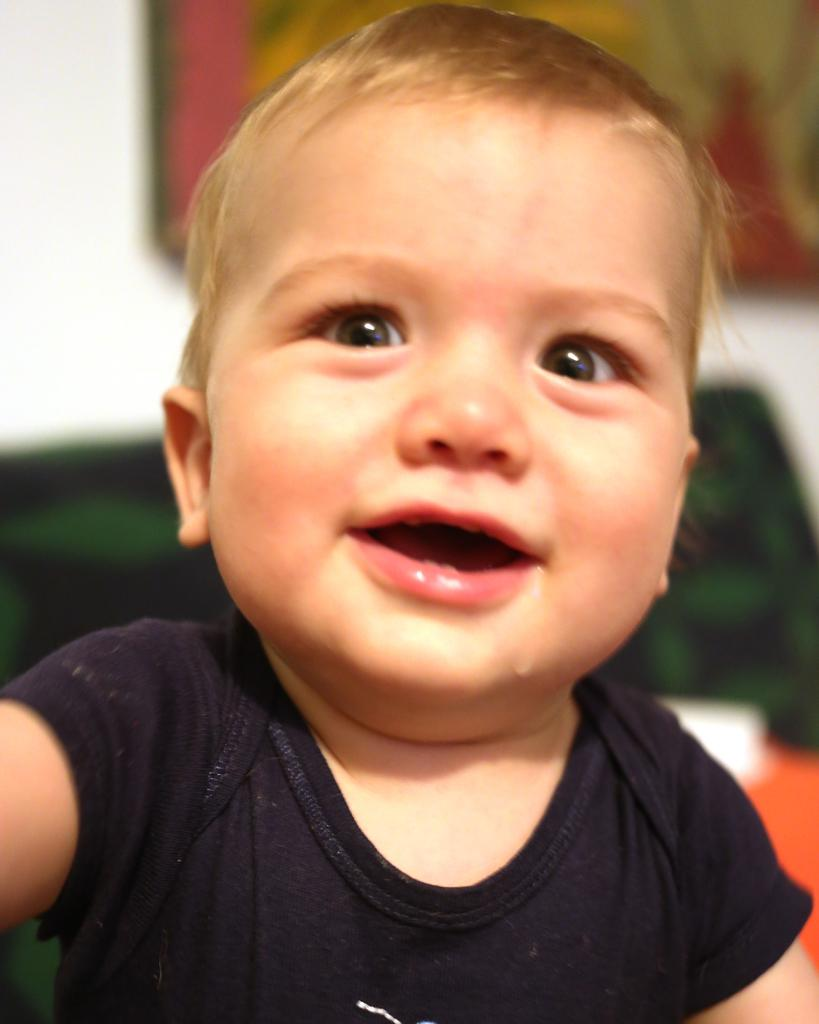What is the main subject of the image? There is a baby in the image. What is the baby doing in the image? The baby is smiling. What color is the dress the baby is wearing? The baby is wearing a black color dress. Can you describe the background of the image? The background of the image is blurred. What type of ornament is hanging from the baby's neck in the image? There is no ornament visible around the baby's neck in the image. 